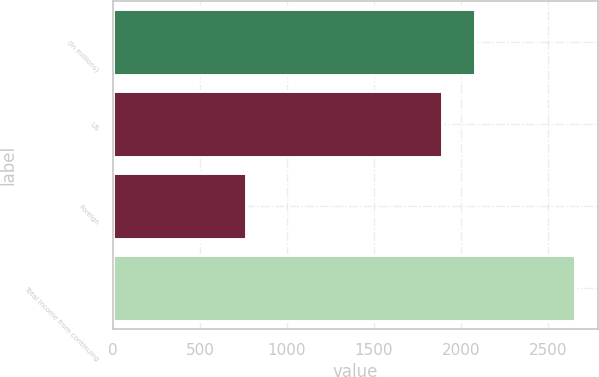Convert chart. <chart><loc_0><loc_0><loc_500><loc_500><bar_chart><fcel>(In millions)<fcel>US<fcel>Foreign<fcel>Total income from continuing<nl><fcel>2082.3<fcel>1893<fcel>764<fcel>2657<nl></chart> 